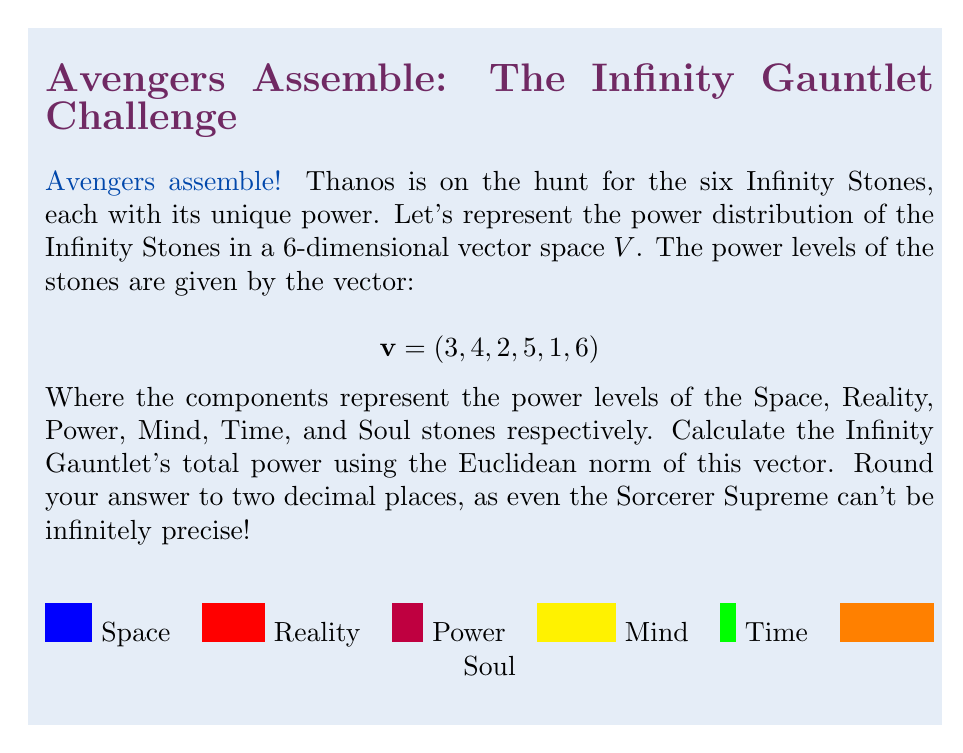Teach me how to tackle this problem. Let's approach this step-by-step, wielding the power of mathematics like Thor's mighty hammer!

1) The Euclidean norm (also known as L2 norm) of a vector $x = (x_1, \ldots, x_n)$ is defined as:

   $$\|x\|_2 = \sqrt{\sum_{i=1}^n |x_i|^2}$$

2) In our case, we have:
   $$v = (3, 4, 2, 5, 1, 6)$$

3) Let's calculate the sum of the squares:
   $$\sum_{i=1}^6 |v_i|^2 = 3^2 + 4^2 + 2^2 + 5^2 + 1^2 + 6^2$$

4) Simplifying:
   $$= 9 + 16 + 4 + 25 + 1 + 36 = 91$$

5) Now, we take the square root:
   $$\|v\|_2 = \sqrt{91} \approx 9.5393920141695$$

6) Rounding to two decimal places:
   $$\|v\|_2 \approx 9.54$$

And there you have it! The Infinity Gauntlet's total power, as precise as Doctor Strange's time manipulations!
Answer: $9.54$ 